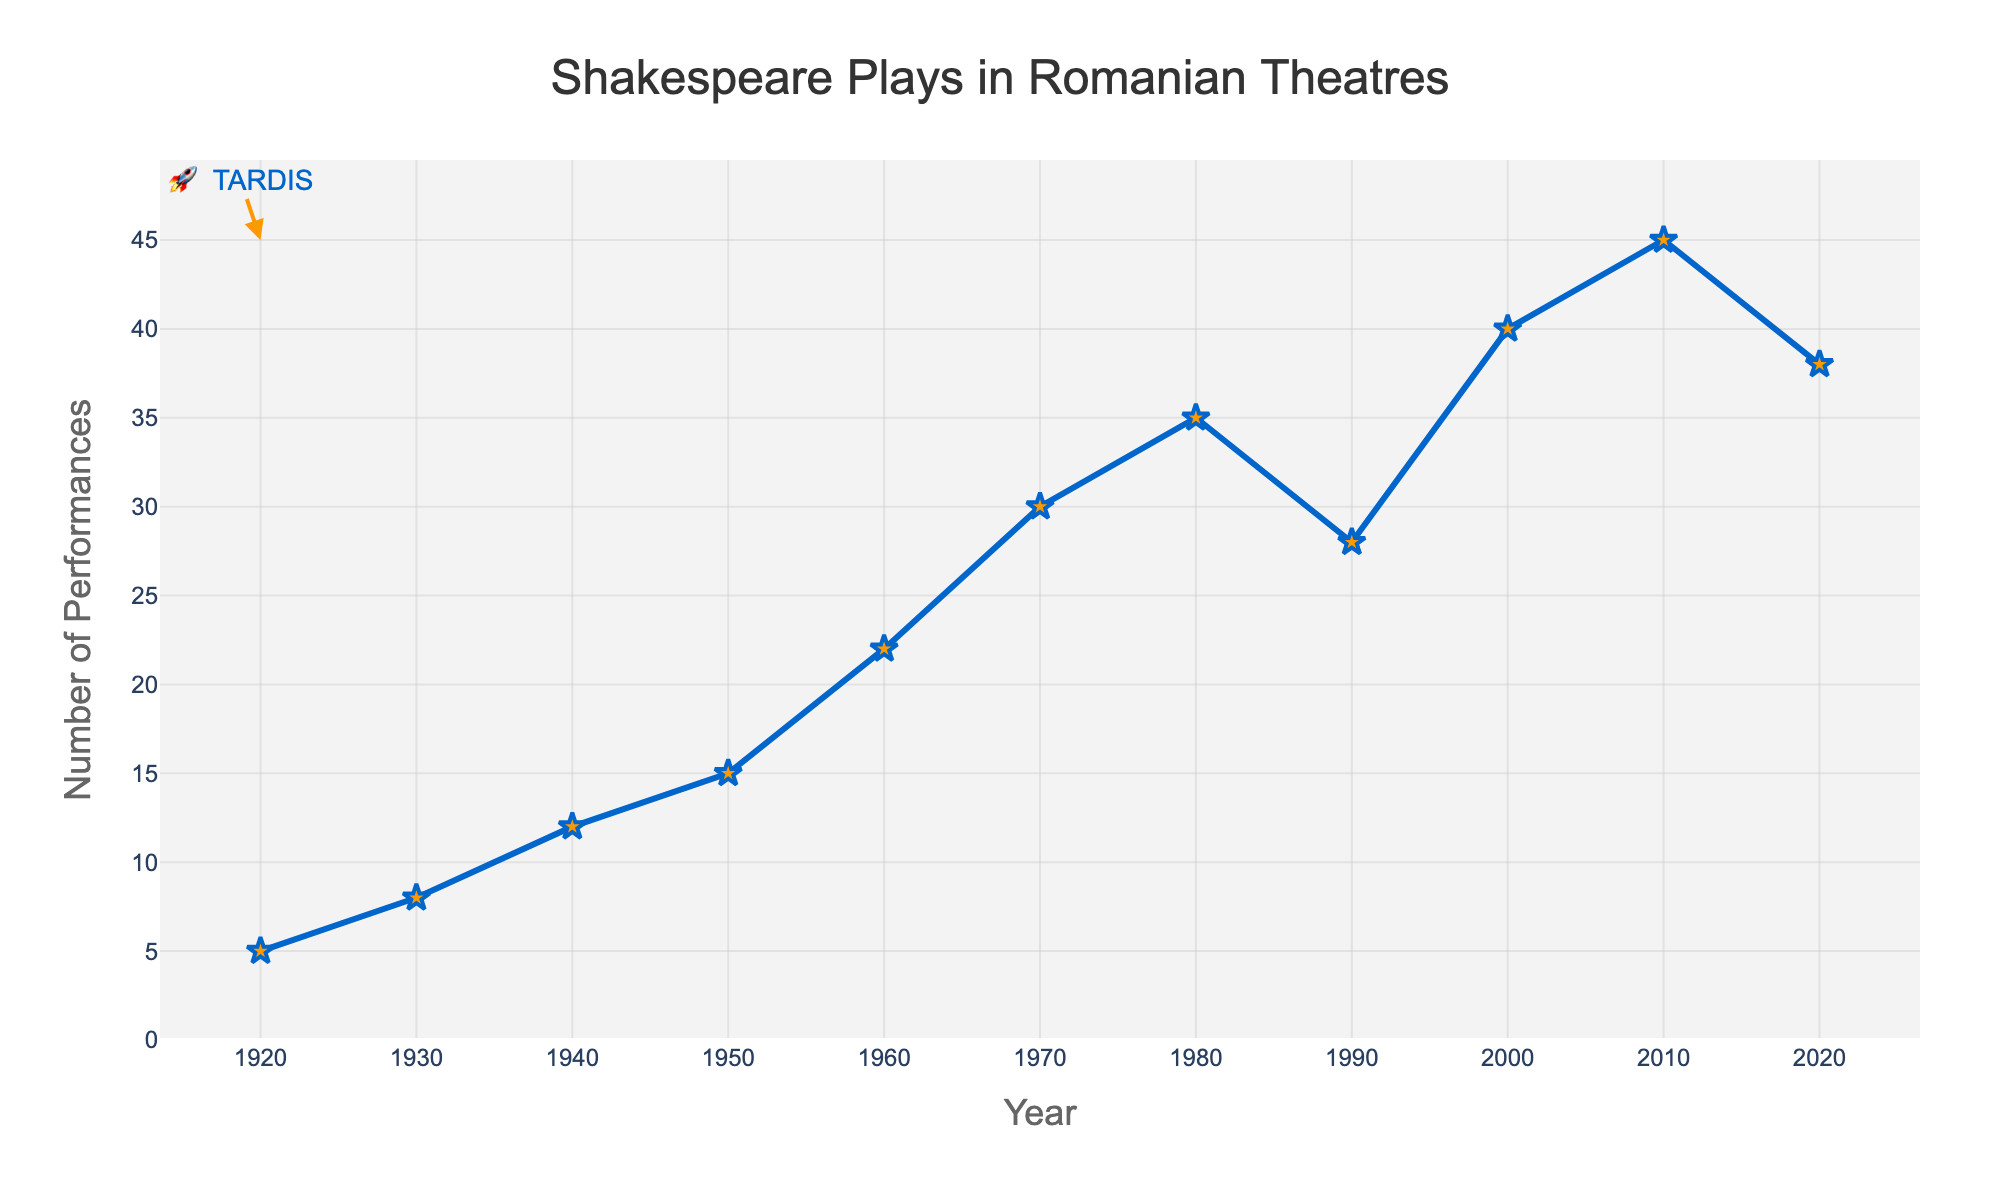What's the trend in the number of Shakespeare performances between 1940 and 1980? To determine the trend, look at the data values for 1940, 1950, 1960, 1970, and 1980. From 1940 to 1980, the performances increase from 12 to 35. This suggests a rising trend.
Answer: Rising trend Which year had the peak number of performances? Look at the highest point on the line chart. The peak number of performances, 45, occurs in 2010.
Answer: 2010 How many more performances were there in 2000 compared to 1920? Subtract the number of performances in 1920 from the number in 2000. That's 40 - 5 = 35.
Answer: 35 In which decade did the number of performances decrease compared to the previous decade? Compare each decade's performance number sequentially to find a decrease. The number of performances decreased from 35 in 1980 to 28 in 1990.
Answer: 1990s What's the average number of performances from 1920 to 2020? Sum all the data points and divide by the number of data points. (5 + 8 + 12 + 15 + 22 + 30 + 35 + 28 + 40 + 45 + 38) / 11 = 278 / 11 ≈ 25.27.
Answer: ~25.27 Which two years have the smallest change in performances, and what is the change? Look for the pair of consecutive years with the smallest difference on the line chart. The smallest change is between 2010 and 2020, which is 45 - 38 = 7.
Answer: 2010 and 2020, 7 What visual element represents the number of performances in each year? Look at the graphical marks on the chart. Star-shaped markers represent the number of performances in each year along the line.
Answer: Star-shaped markers Compare the number of performances in 1950 and 1970, which had more? Look at the respective points in 1950 and 1970 on the line chart. In 1950, there were 15 performances and in 1970, there were 30 performances.
Answer: 1970 had more What is the difference in the number of performances between the year with the highest and the year with the lowest? The peak is 45 performances in 2010 and the lowest is 5 performances in 1920. The difference is 45 - 5 = 40.
Answer: 40 How would you describe the overall trend in performances from 1920 to 2020? Observe the entire line chart from left to right. There are fluctuations, but there is an overall increasing trend with peaks and troughs along the century.
Answer: Overall increasing trend 